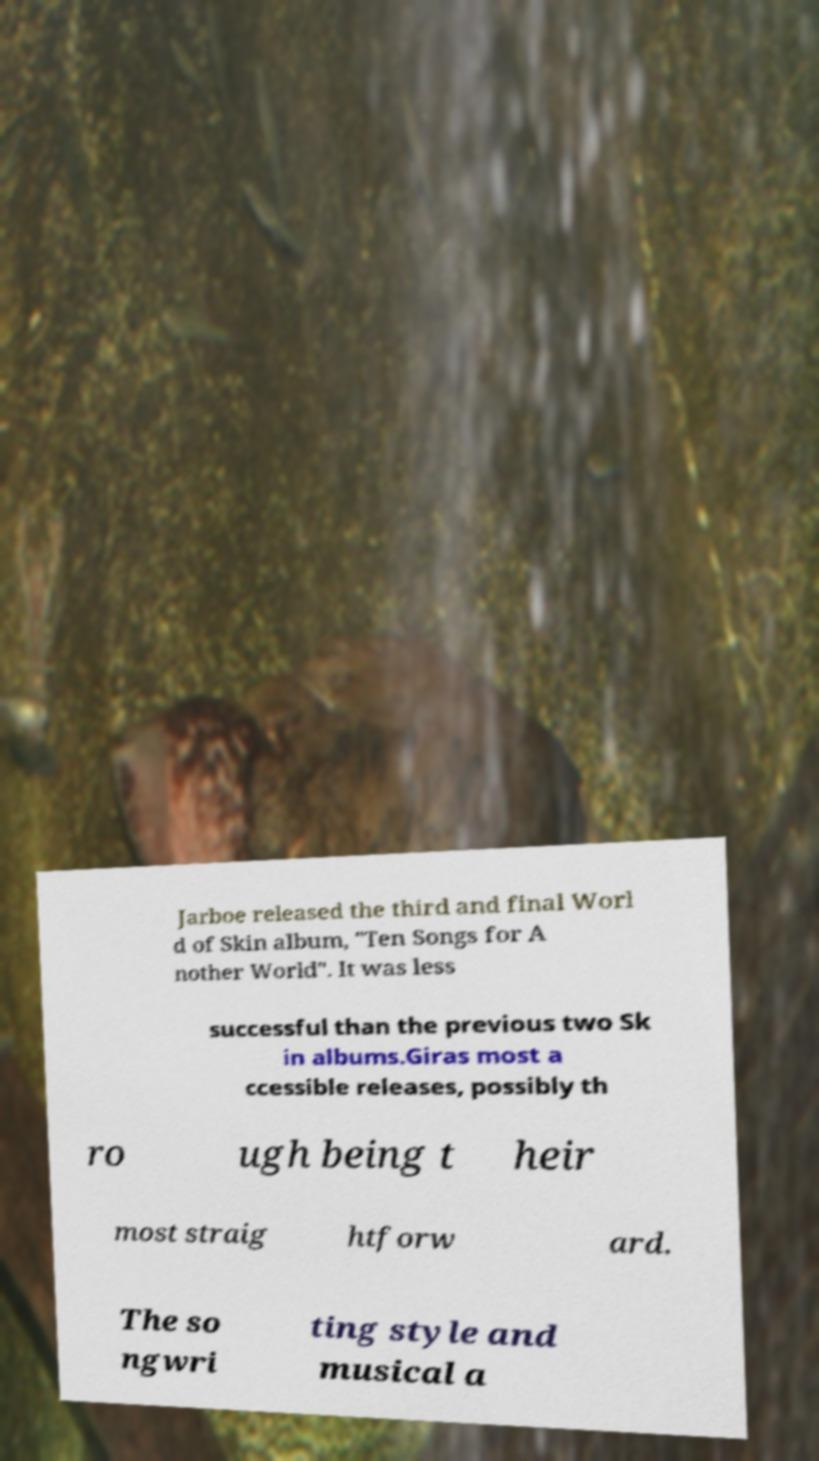Please identify and transcribe the text found in this image. Jarboe released the third and final Worl d of Skin album, "Ten Songs for A nother World". It was less successful than the previous two Sk in albums.Giras most a ccessible releases, possibly th ro ugh being t heir most straig htforw ard. The so ngwri ting style and musical a 